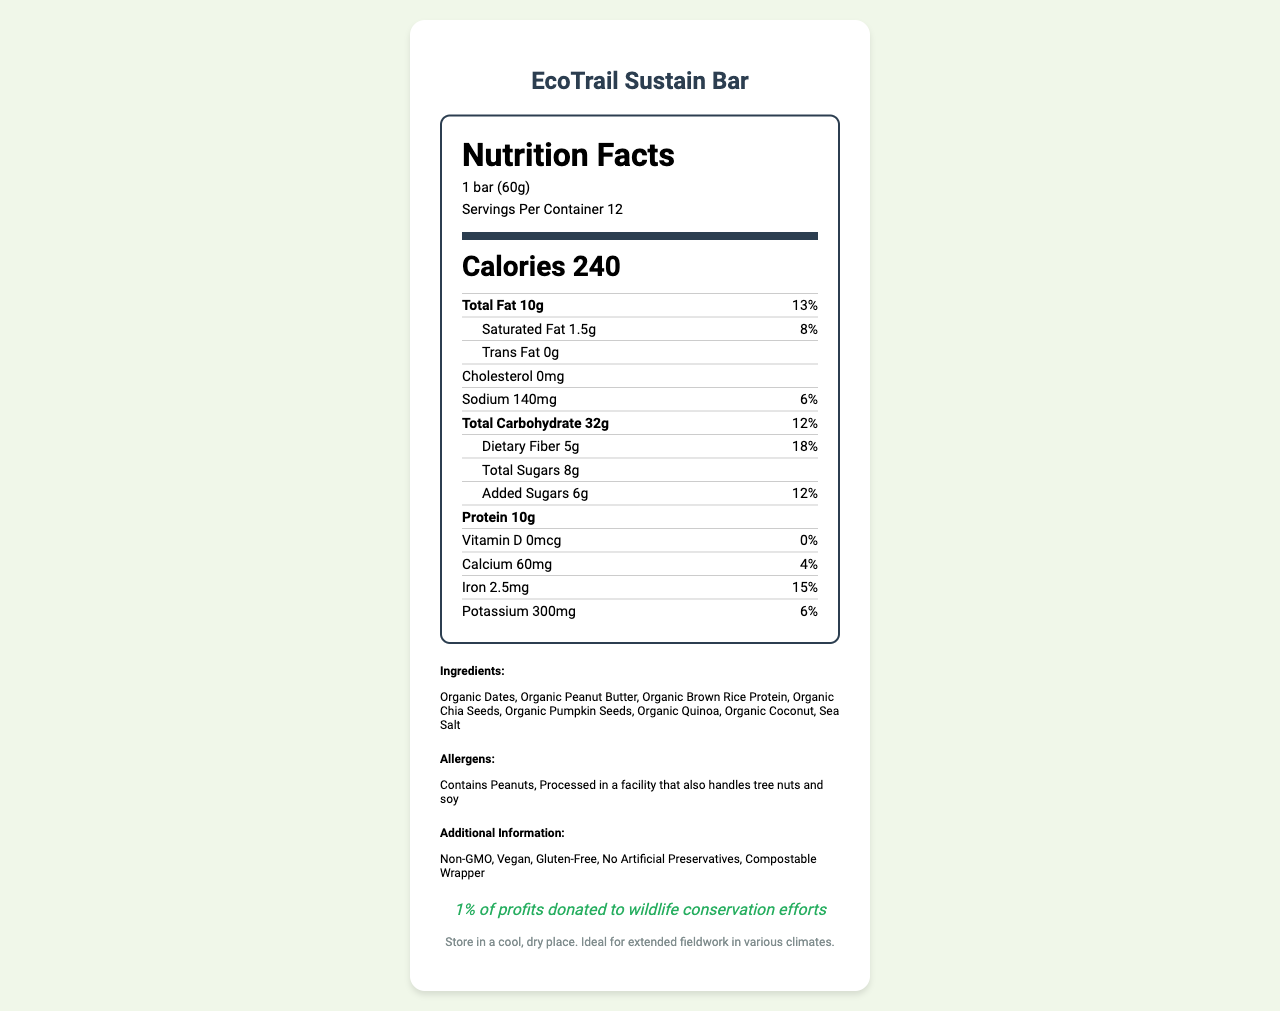what is the serving size? The serving size is explicitly mentioned as "1 bar (60g)" under the serving information.
Answer: 1 bar (60g) how many servings are there per container? The document lists "Servings Per Container: 12" in the serving information section.
Answer: 12 how many grams of protein does one serving contain? Under the nutrient section, Protein is listed as containing 10g per serving.
Answer: 10g what is the daily value percentage of dietary fiber per serving? Dietary Fiber has a daily value percentage of 18%, as indicated in the nutrient section.
Answer: 18% what is the ingredient list? The ingredients are explicitly listed under the ingredients section.
Answer: Organic Dates, Organic Peanut Butter, Organic Brown Rice Protein, Organic Chia Seeds, Organic Pumpkin Seeds, Organic Quinoa, Organic Coconut, Sea Salt how much iron is there per serving? Iron is listed with an amount of 2.5mg per serving in the nutrient section.
Answer: 2.5mg what are the allergen warnings? The allergens are stated under the allergens section in the document.
Answer: Contains Peanuts, Processed in a facility that also handles tree nuts and soy how many calories are in one bar? The document lists the calorie count as 240 per bar in bold under the serving information.
Answer: 240 which of the following claims is NOT true about the EcoTrail Sustain Bar? A. Vegan B. Contains Artificial Preservatives C. Non-GMO D. Gluten-Free The additional info section claims the product is "Non-GMO, Vegan, Gluten-Free, No Artificial Preservatives, Compostable Wrapper." Therefore, B (Contains Artificial Preservatives) is the one not true.
Answer: B how much calcium is there per serving? The nutrient section indicates that there are 60mg of calcium per serving.
Answer: 60mg Is the bar free of gluten? According to the additional info section, the product is labeled "Gluten-Free."
Answer: Yes what is the total amount of sugars in one serving, combining both natural and added? The nutrient section lists the total sugars as 8g.
Answer: 8g what percentage of profits are donated to wildlife conservation efforts? The conservation message mentions that "1% of profits donated to wildlife conservation efforts."
Answer: 1% how should the EcoTrail Sustain Bar be stored? The storage instructions explicitly state this information.
Answer: Store in a cool, dry place. Ideal for extended fieldwork in various climates. does the product contain any cholesterol? The document states there is "0mg" of cholesterol.
Answer: No Is there any Vitamin D in the EcoTrail Sustain Bar? The nutrient section indicates that the Vitamin D amount is "0mcg" with a daily value of "0%."
Answer: No Is there added sugar in the bar? The nutrient section lists "Added Sugars: 6g (12%)".
Answer: Yes summarize the entire document. The document provides the nutritional information, ingredients, storage instructions, allergen warnings, and additional eco-friendly claims for the EcoTrail Sustain Bar, emphasizing its suitability for fieldwork.
Answer: The EcoTrail Sustain Bar is a plant-based, eco-friendly snack bar designed for conservation teams. Each bar serves 240 calories with various nutrients including 10g of protein and 5g of dietary fiber. The ingredients are organic, non-GMO, vegan, and gluten-free with no artificial preservatives, and it comes with a compostable wrapper. The product contains allergen warnings for peanuts and other possible tree nuts and soy. An important note is that 1% of its profits go towards wildlife conservation efforts, and it requires storage in a cool, dry place. Is there any information about the manufacturing location of the EcoTrail Sustain Bar? The document does not provide any specific details about the manufacturing location.
Answer: Not enough information 